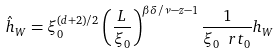<formula> <loc_0><loc_0><loc_500><loc_500>\hat { h } _ { W } = \xi _ { 0 } ^ { ( d + 2 ) / 2 } \left ( \frac { L } { \xi _ { 0 } } \right ) ^ { \beta \delta / \nu - z - 1 } \frac { 1 } { \xi _ { 0 } \ r t _ { 0 } } h _ { W }</formula> 